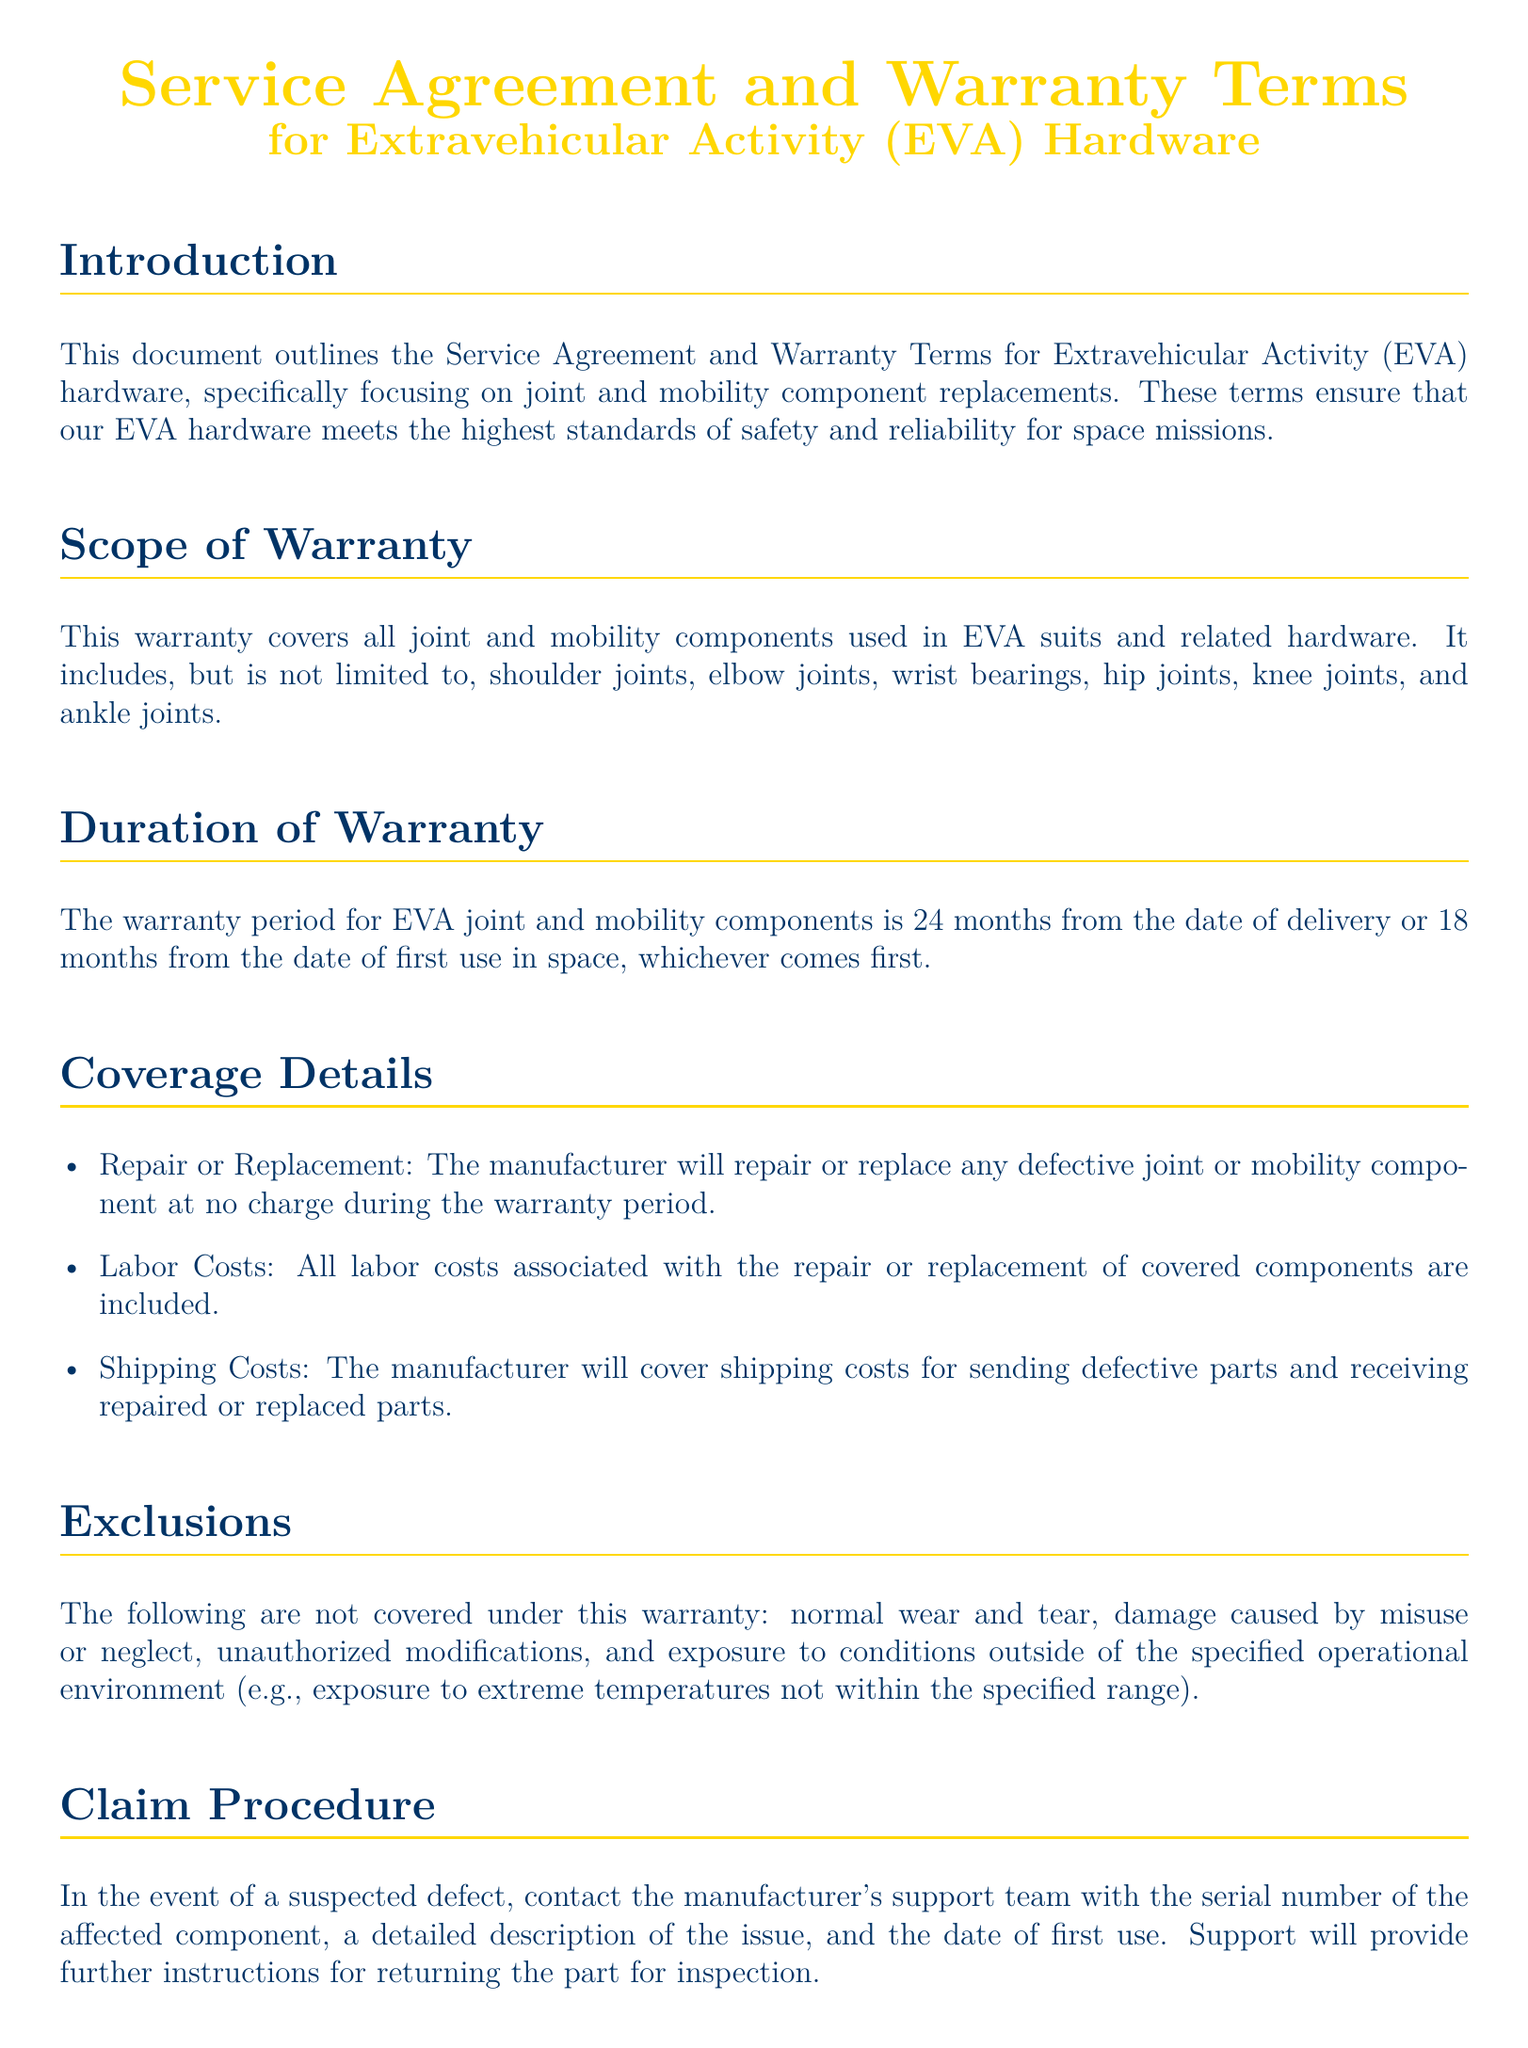What components are covered under this warranty? The warranty covers all joint and mobility components used in EVA suits and related hardware, specifically listed in the scope.
Answer: joint and mobility components What is the duration of the warranty period? The duration is specified in months from either delivery or first use in space.
Answer: 24 months What are the exclusions from the warranty coverage? The document lists specific scenarios where coverage does not apply, such as normal wear and tear and damage caused by misuse.
Answer: normal wear and tear, damage caused by misuse or neglect, unauthorized modifications, exposure to conditions outside of specified operational environment Who is responsible for shipping costs related to warranty claims? The details regarding shipping costs during the claim process are outlined in the coverage details.
Answer: The manufacturer What action should be taken for a suspected defect? The claim procedure specifies that contacting support with detailed information is the initial step in reporting a defect.
Answer: Contact the manufacturer's support team What does the manufacturer guarantee in terms of quality and safety? The document states a collaborative effort with space agencies to ensure compliance, indicating a commitment to quality.
Answer: Continuous testing and certification in collaboration with space agencies What limitations are placed on the manufacturer's liability? The limitations described in the warranty clarify the extent of the manufacturer's responsibility in case of defects.
Answer: Incidental or consequential damages Under what laws is the warranty governed? The applicable law section specifies the jurisdiction governing the warranty terms.
Answer: The laws of the state in which the manufacturer is headquartered 